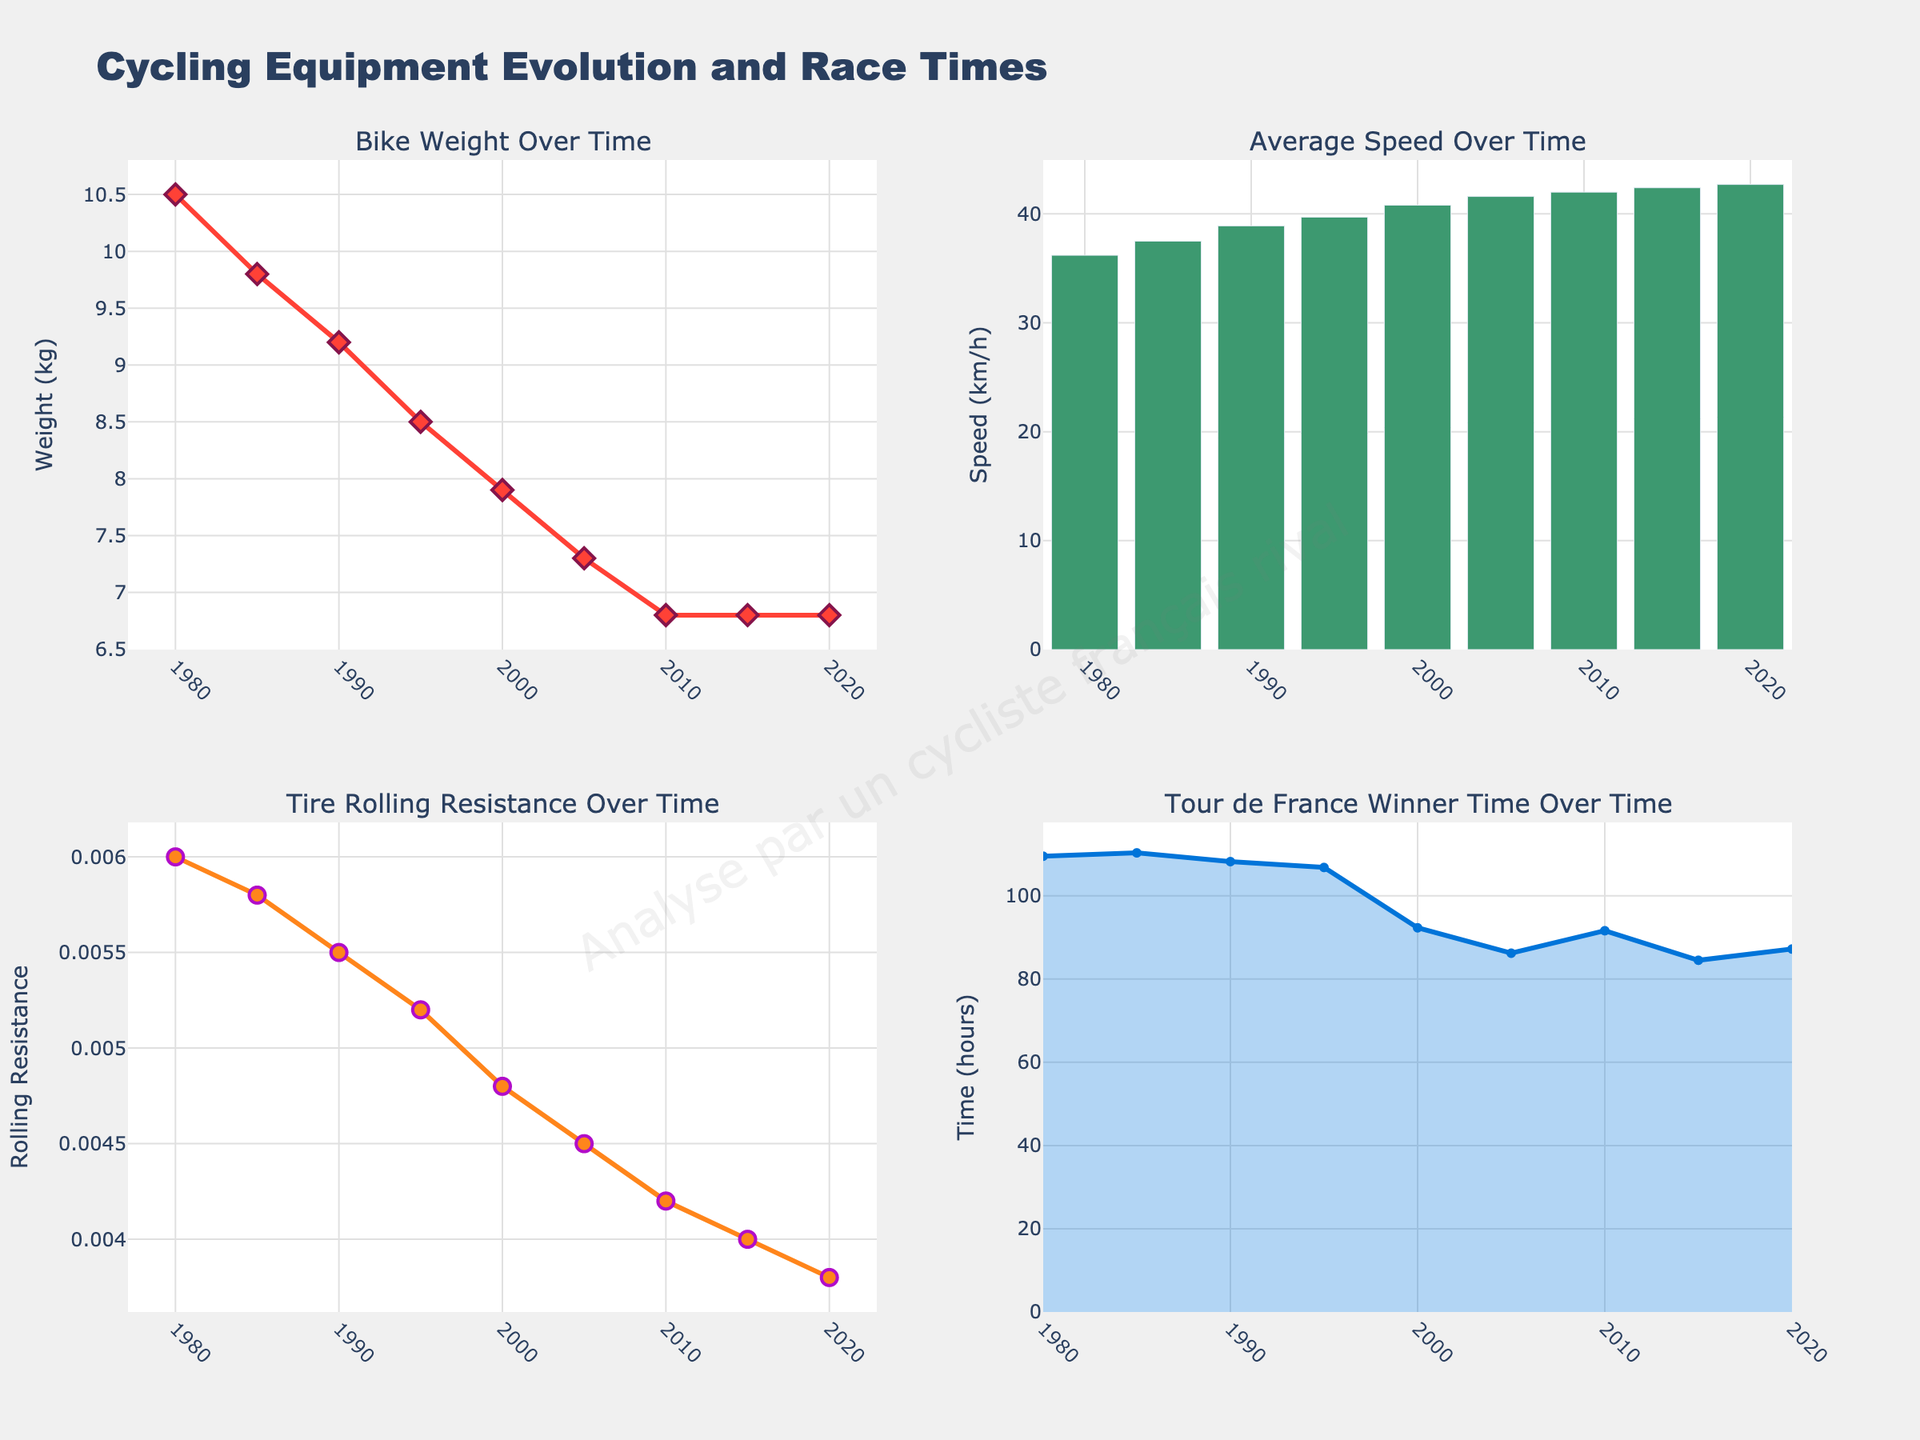What's the title of the figure? The title is clearly indicated at the top of the figure, reading "Cycling Equipment Evolution and Race Times".
Answer: Cycling Equipment Evolution and Race Times What is the overall trend in bike weight over time? The subplot "Bike Weight Over Time" shows a decreasing trend. By observing the plotted lines and markers, we see that bike weight has reduced from 10.5 kg in 1980 to 6.8 kg in 2020.
Answer: Decreasing Which year had the fastest average speed, according to the bar plot? By examining the "Average Speed Over Time" bar plot, we see the tallest bar represents the year with the fastest speed which is 2020 with an average speed of 42.7 km/h.
Answer: 2020 How did the tire rolling resistance change from 1980 to 2020? The subplot "Tire Rolling Resistance Over Time" indicates a continuous decline, starting at 0.0060 in 1980 and dropping to 0.0038 in 2020, suggesting tire rolling resistance decreased over these years.
Answer: Decreased What does the filled area under the line represent in the "Tour de France Winner Time Over Time" subplot? This subplot uses an area to fill under the trend line, typically representing the magnitude of the data over the years. Here, it symbolizes the winner's time in hours, which shows the variation more visually.
Answer: Winner's time in hours How much did the bike weight decrease from 1980 to 2020? To find the decrease, subtract the 2020 value (6.8 kg) from the 1980 value (10.5 kg). The bike weight decreased by 10.5 - 6.8 = 3.7 kg.
Answer: 3.7 kg Which subplot uses a scatter plot to represent data? By looking at the different plot types in each subplot, both the "Bike Weight Over Time" and "Tire Rolling Resistance Over Time" utilize scatter plots, indicated by lines and markers.
Answer: "Bike Weight Over Time" and "Tire Rolling Resistance Over Time" During which decade did the Tour de France winner's time drop significantly? From the "Tour de France Winner Time Over Time" subplot, a noticeable significant drop in time can be seen between 1995 and 2000. In 2000, the time drastically drops to 92.3 hours from 106.8 hours in 1995.
Answer: 1995-2000 What is the general relationship between average speed and bike weight over time? By observing both the "Average Speed Over Time" and "Bike Weight Over Time" subplots, it's apparent that as bike weight decreases, the average speed tends to increase inversely, indicating an indirect relationship.
Answer: Inversely related What is the color used to represent the "Tire Rolling Resistance" line? The tire rolling resistance line appears in orange with markers having a purple outline, signifying the measurements.
Answer: Orange 